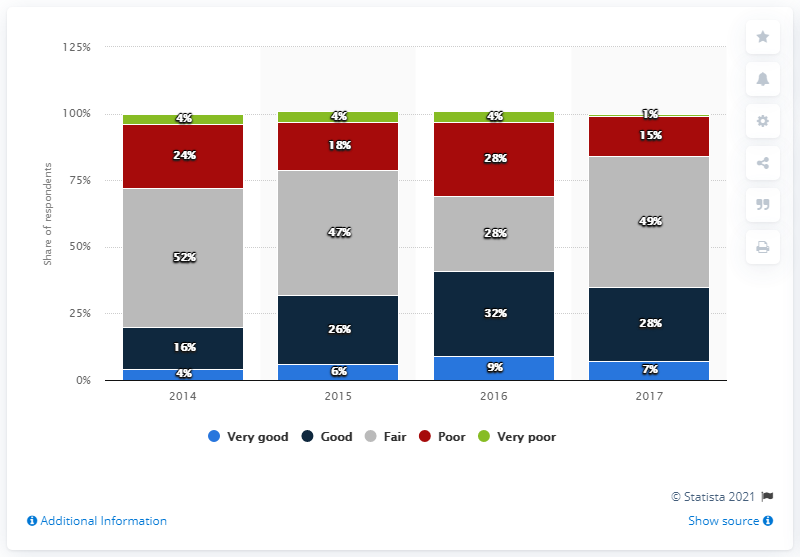Specify some key components in this picture. According to the respondents, there is a high expectation of good prospects for investment in the business park subsector in 2017. The ratio of the smallest light blue bar to the largest green bar is 1 to 1. The number of colors used in the bar graph is five. 